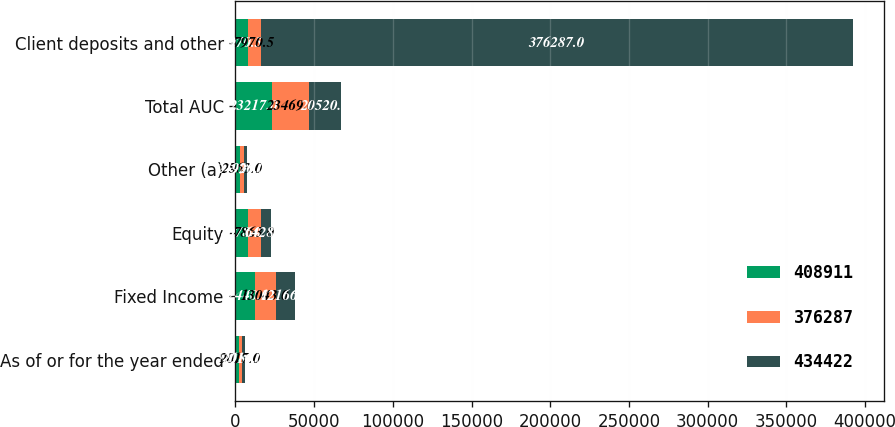Convert chart to OTSL. <chart><loc_0><loc_0><loc_500><loc_500><stacked_bar_chart><ecel><fcel>As of or for the year ended<fcel>Fixed Income<fcel>Equity<fcel>Other (a)<fcel>Total AUC<fcel>Client deposits and other<nl><fcel>408911<fcel>2018<fcel>12440<fcel>8078<fcel>2699<fcel>23217<fcel>7970.5<nl><fcel>376287<fcel>2017<fcel>13043<fcel>7863<fcel>2563<fcel>23469<fcel>7970.5<nl><fcel>434422<fcel>2016<fcel>12166<fcel>6428<fcel>1926<fcel>20520<fcel>376287<nl></chart> 